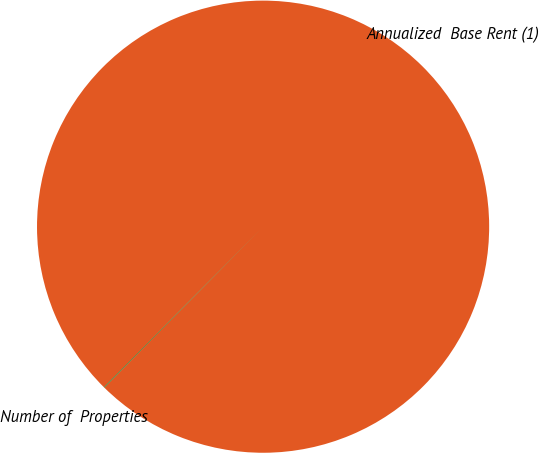Convert chart. <chart><loc_0><loc_0><loc_500><loc_500><pie_chart><fcel>Annualized  Base Rent (1)<fcel>Number of  Properties<nl><fcel>99.96%<fcel>0.04%<nl></chart> 